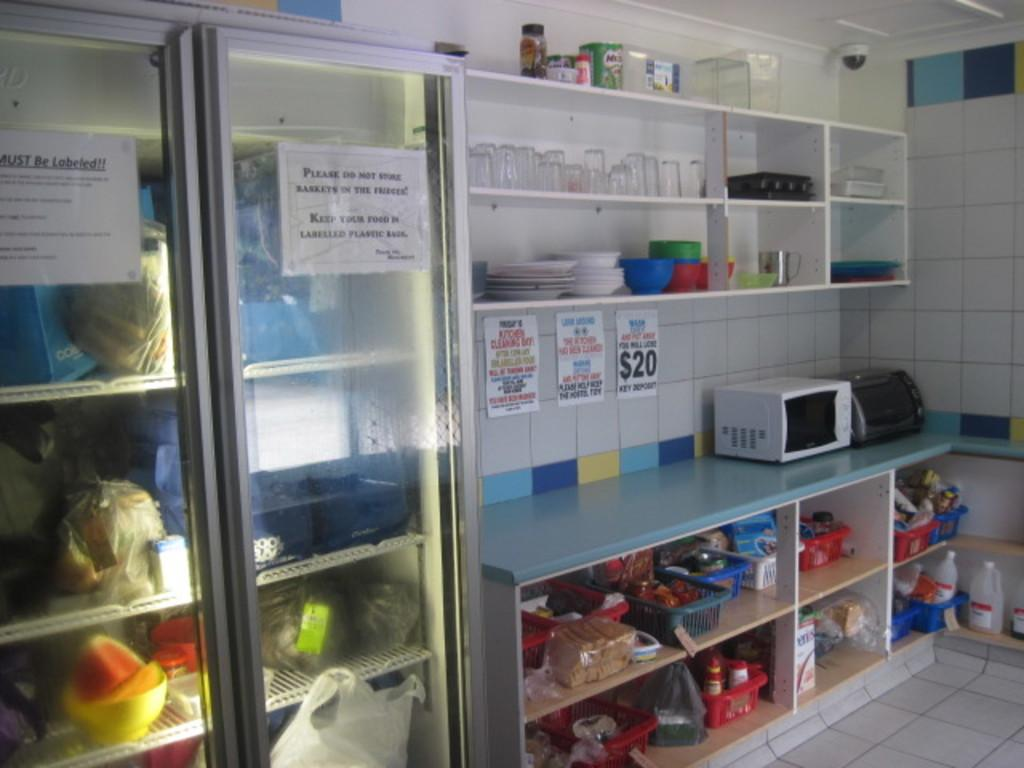Provide a one-sentence caption for the provided image. A kitchen or break room area with a refrigerator that has a note attached to the door reminding people to keep their food in labeled boxes. 